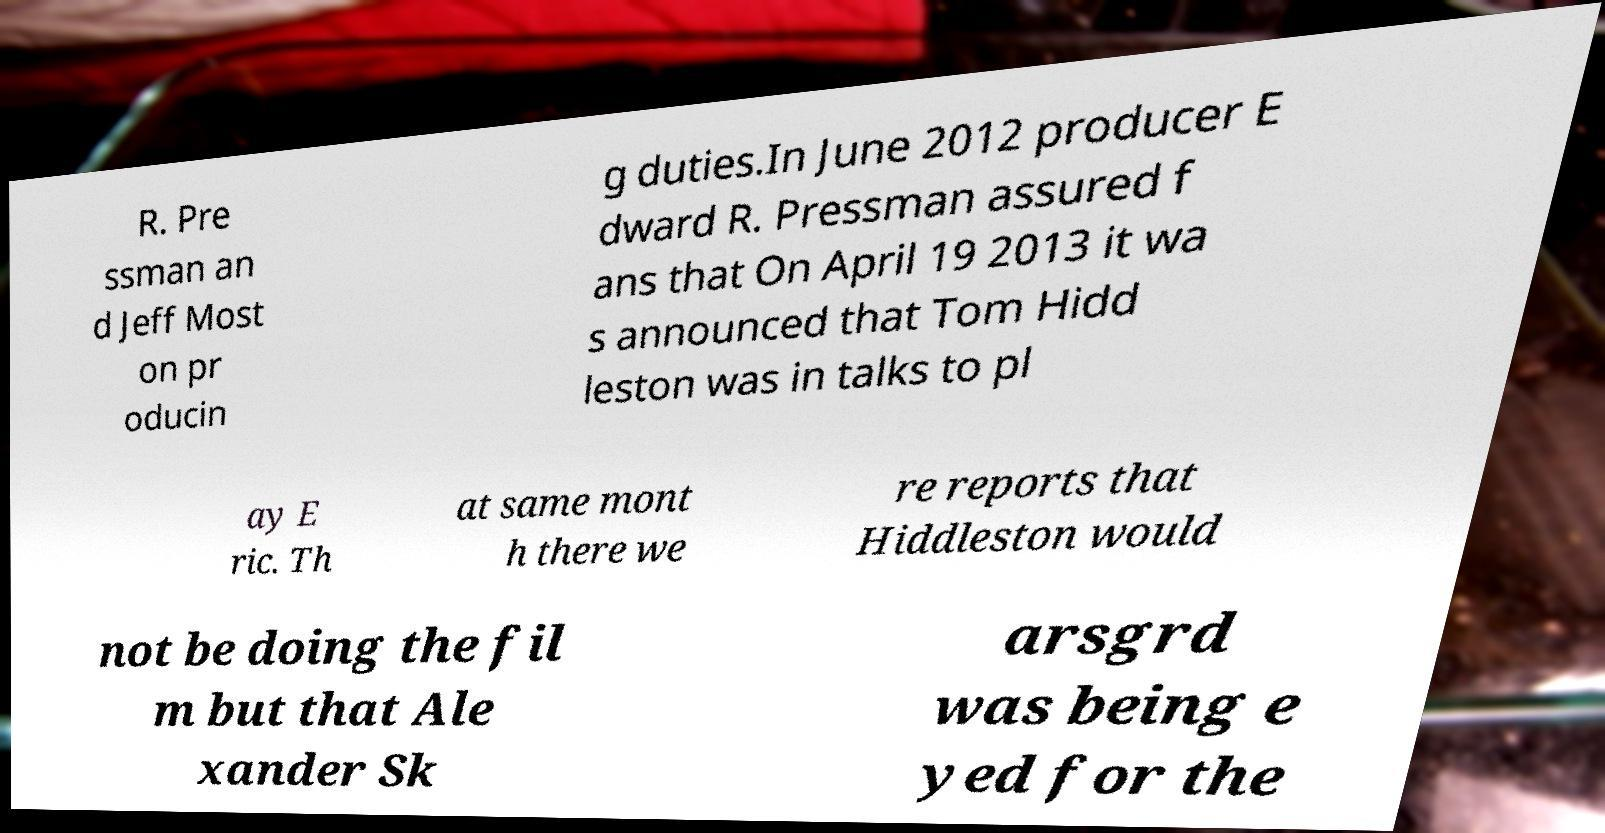Please identify and transcribe the text found in this image. R. Pre ssman an d Jeff Most on pr oducin g duties.In June 2012 producer E dward R. Pressman assured f ans that On April 19 2013 it wa s announced that Tom Hidd leston was in talks to pl ay E ric. Th at same mont h there we re reports that Hiddleston would not be doing the fil m but that Ale xander Sk arsgrd was being e yed for the 